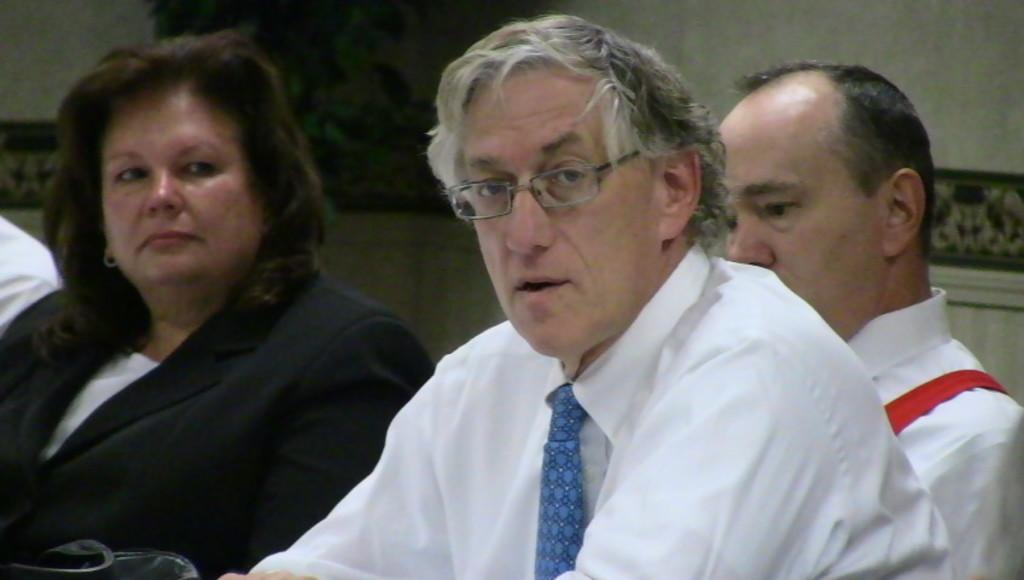What can be seen in the foreground of the image? There are people in the foreground of the image. Can you describe any specific details about one of the people? One person in the foreground is wearing spectacles. What is visible in the background of the image? There is a wall and photo frames in the background of the image. What type of seed can be seen growing on the person's toe in the image? There is no seed or growth on anyone's toe in the image. How many balloons are visible in the image? There are no balloons present in the image. 